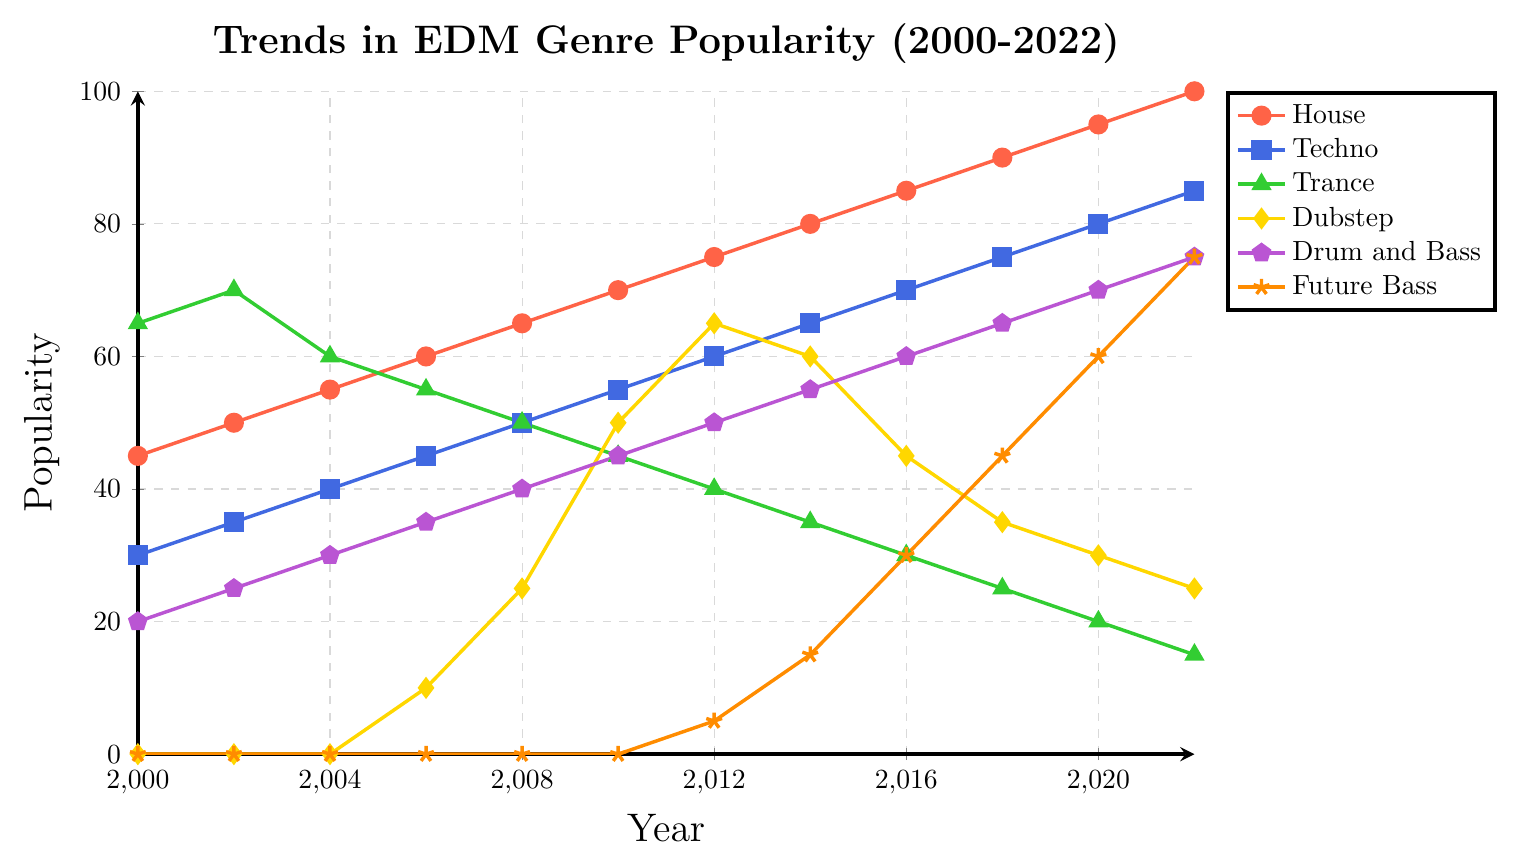What EDM genre had the highest popularity in 2000? By referencing the y-axis values at the year 2000 for each genre, Trance has the highest value at 65.
Answer: Trance Between which years did Dubstep see the steepest rise in popularity? By checking the positive slopes in the Dubstep plot line, the popularity rises steeply from 2006 to 2010.
Answer: 2006-2010 How did the popularity of Future Bass change between 2008 and 2018? Observing the values, Future Bass went from 0 in 2008 to 45 in 2018, indicating a steady increase in popularity.
Answer: Increased steadily Which genre showed a decrease in popularity from 2000 to 2022? Checking all genre trends from 2000 to 2022, only Trance shows a consistent decrease in popularity.
Answer: Trance What was the combined popularity of House and Techno in the year 2016? Adding the values for House (85) and Techno (70) in the year 2016 gives 85 + 70 = 155.
Answer: 155 Compare the popularity of Drum and Bass and Dubstep in 2020. Which was more popular? In 2020, Drum and Bass is at 70 and Dubstep is at 30. Drum and Bass has a higher value.
Answer: Drum and Bass In which year did House surpass a popularity of 80? By looking at the progression of the House trend, it surpasses 80 in the year 2014.
Answer: 2014 What is the average popularity of Techno across all the years? The values for Techno are 30, 35, 40, 45, 50, 55, 60, 65, 70, 75, 80, 85. The sum is 690, and the average is 690/12 = 57.5.
Answer: 57.5 Between which years did the popularity of Drum and Bass increase from 25 to 40? By observing the values, Drum and Bass goes from 25 in 2002 to 40 in 2008.
Answer: 2002-2008 What color represents the Trance genre in the plot? By checking the legend, Trance is represented by the green color.
Answer: Green 